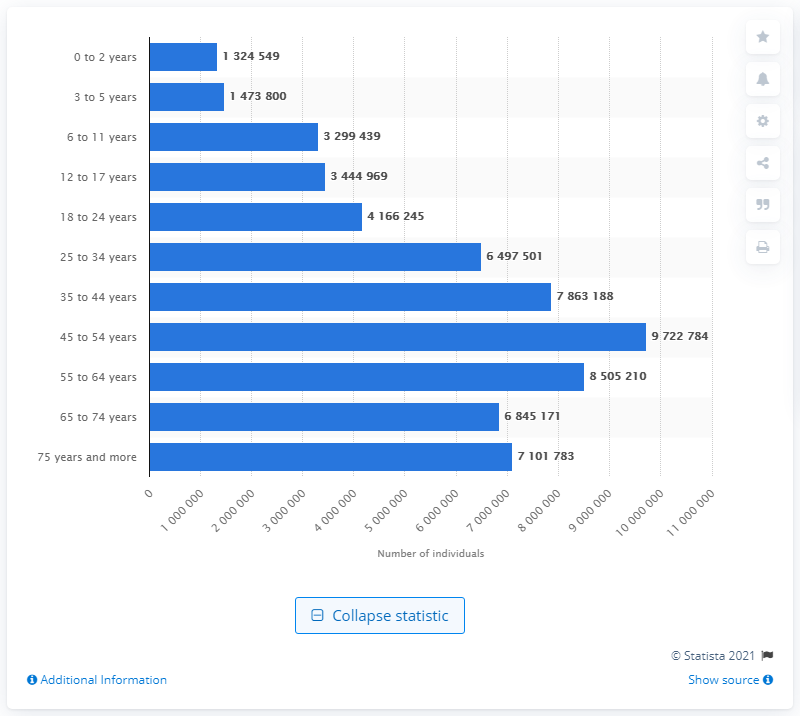Specify some key components in this picture. As of 2019, it is estimated that approximately 972,2784 people resided in Italy. 